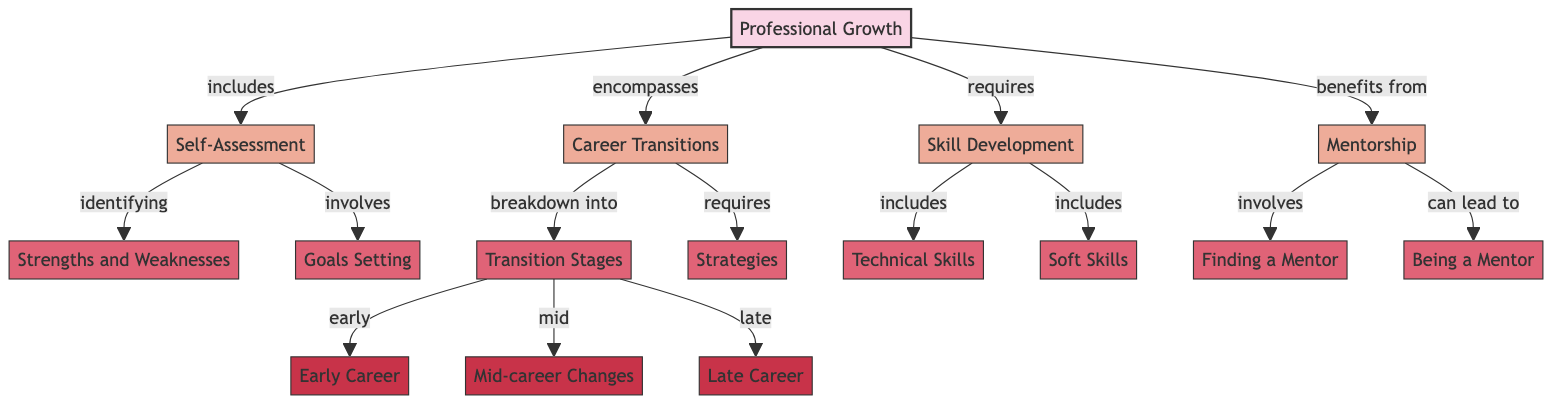What is the main concept of the diagram? The main concept, labeled at the top of the diagram, focuses on the overarching theme of the concept map, which is "Professional Growth."
Answer: Professional Growth How many subtopics are related to professional growth? By counting the directly connected nodes that are labeled as subtopics, there are three subtopics, which are "Self-Assessment," "Career Transitions," and "Skill Development," included in the diagram.
Answer: 3 What detail is associated with self-assessment? The diagram shows that "Strengths and Weaknesses" and "Goals Setting" are details that relate to the subtopic "Self-Assessment," which indicate areas to evaluate personally.
Answer: Strengths and Weaknesses What are the three stages of career transitions? In the section labeled "Transition Stages," the diagram specifies three stages: "Early Career," "Mid-career Changes," and "Late Career," each defined clearly as an example of career transitions.
Answer: Early Career, Mid-career Changes, Late Career Which subtopic is related to mentorship? The node labeled "Mentorship" is a subtopic under "Professional Growth," and it details the processes involved in gaining and providing mentorship in a professional context.
Answer: Mentorship What does "Career Transitions" require according to the diagram? The diagram indicates that "Career Transitions" requires "Strategies," which means having a plan or approach to navigate through career changes effectively.
Answer: Strategies Which details are included under skill development? According to the diagram, "Technical Skills" and "Soft Skills" are the details associated with the subtopic "Skill Development," representing the types of skills important for professional growth.
Answer: Technical Skills, Soft Skills What action is involved in finding a mentor? The detail listed under the subtopic "Mentorship" that specifically pertains to this action is "Finding a Mentor," indicating the effort or process to seek guidance from a more experienced individual.
Answer: Finding a Mentor What can mentorship lead to? The diagram states that mentorship can lead to "Being a Mentor," indicating the reciprocal nature of mentoring relationships where one who receives mentorship may eventually offer it to others.
Answer: Being a Mentor 